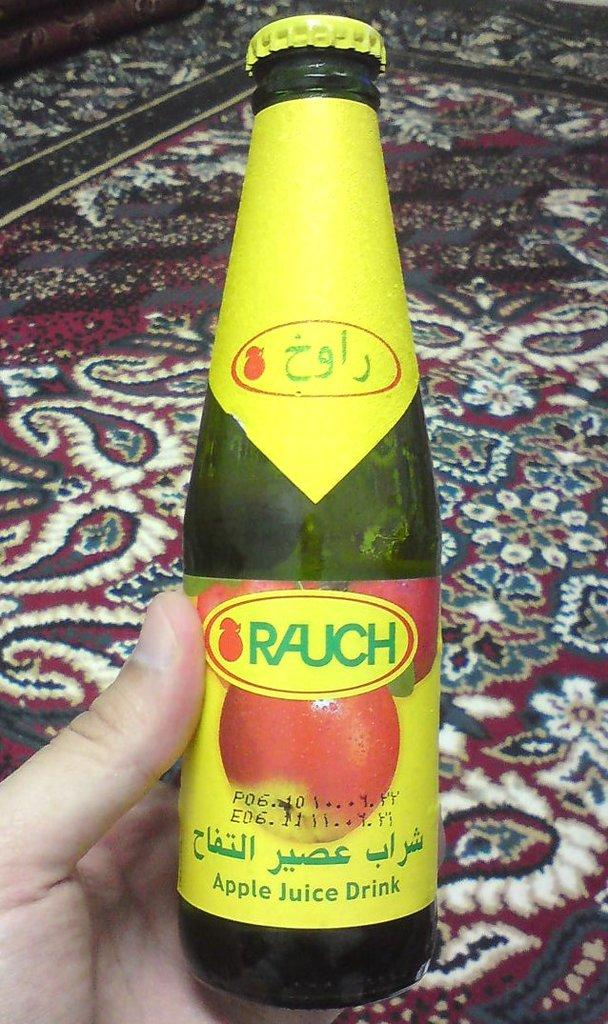<image>
Give a short and clear explanation of the subsequent image. A bottle with a yellow label and the word Rauch on it is being held in a hand. 